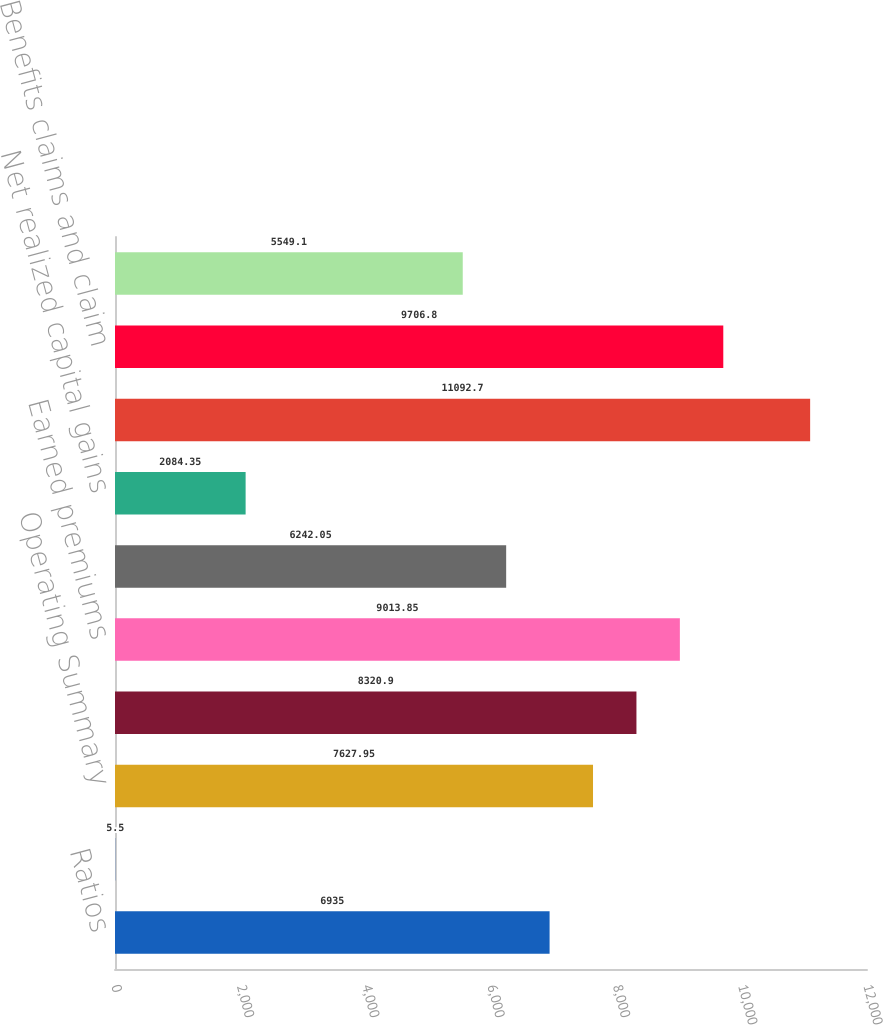<chart> <loc_0><loc_0><loc_500><loc_500><bar_chart><fcel>Ratios<fcel>Group Benefits Segment - After<fcel>Operating Summary<fcel>Fee income<fcel>Earned premiums<fcel>Net investment income 1<fcel>Net realized capital gains<fcel>Total revenues<fcel>Benefits claims and claim<fcel>Insurance operating costs and<nl><fcel>6935<fcel>5.5<fcel>7627.95<fcel>8320.9<fcel>9013.85<fcel>6242.05<fcel>2084.35<fcel>11092.7<fcel>9706.8<fcel>5549.1<nl></chart> 